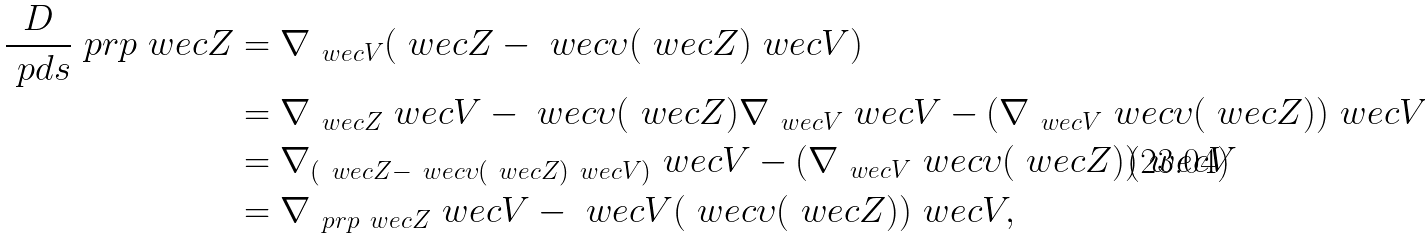<formula> <loc_0><loc_0><loc_500><loc_500>\frac { D } { \ p d s } \ p r p \ w e c { Z } & = \nabla _ { \ w e c { V } } ( \ w e c { Z } - \ w e c { \upsilon } ( \ w e c { Z } ) \ w e c { V } ) \\ & = \nabla _ { \ w e c { Z } } \ w e c { V } - \ w e c { \upsilon } ( \ w e c { Z } ) \nabla _ { \ w e c { V } } \ w e c { V } - ( \nabla _ { \ w e c { V } } \ w e c { \upsilon } ( \ w e c { Z } ) ) \ w e c { V } \\ & = \nabla _ { ( \ w e c { Z } - \ w e c { \upsilon } ( \ w e c { Z } ) \ w e c { V } ) } \ w e c { V } - ( \nabla _ { \ w e c { V } } \ w e c { \upsilon } ( \ w e c { Z } ) ) \ w e c { V } \\ & = \nabla _ { \ p r p \ w e c { Z } } \ w e c { V } - \ w e c { V } ( \ w e c { \upsilon } ( \ w e c { Z } ) ) \ w e c { V } ,</formula> 